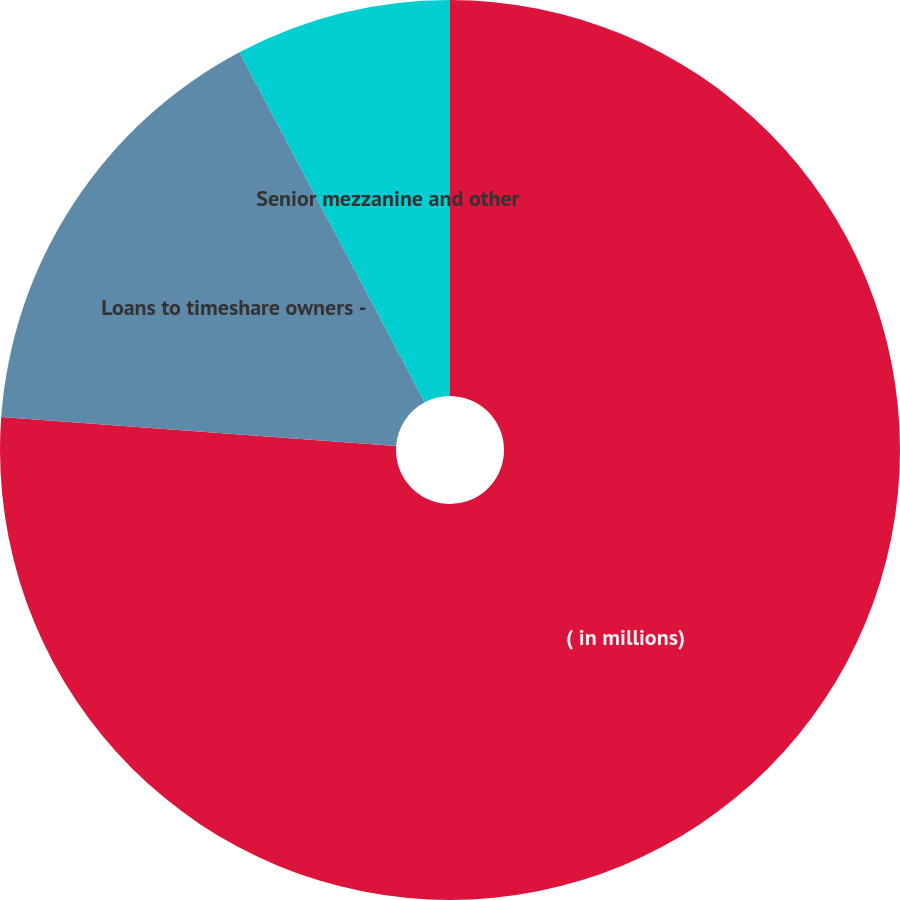Convert chart. <chart><loc_0><loc_0><loc_500><loc_500><pie_chart><fcel>( in millions)<fcel>Loans to timeshare owners -<fcel>Senior mezzanine and other<nl><fcel>76.17%<fcel>16.08%<fcel>7.75%<nl></chart> 